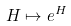Convert formula to latex. <formula><loc_0><loc_0><loc_500><loc_500>H \mapsto e ^ { H }</formula> 